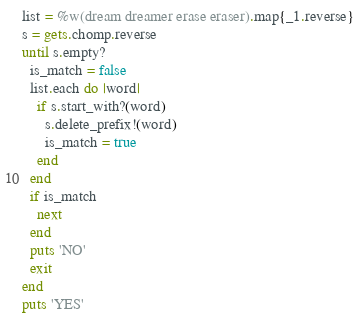Convert code to text. <code><loc_0><loc_0><loc_500><loc_500><_Ruby_>list = %w(dream dreamer erase eraser).map{_1.reverse}
s = gets.chomp.reverse
until s.empty?
  is_match = false
  list.each do |word|
    if s.start_with?(word)
      s.delete_prefix!(word)
      is_match = true
    end
  end
  if is_match
    next
  end
  puts 'NO'
  exit
end
puts 'YES'</code> 